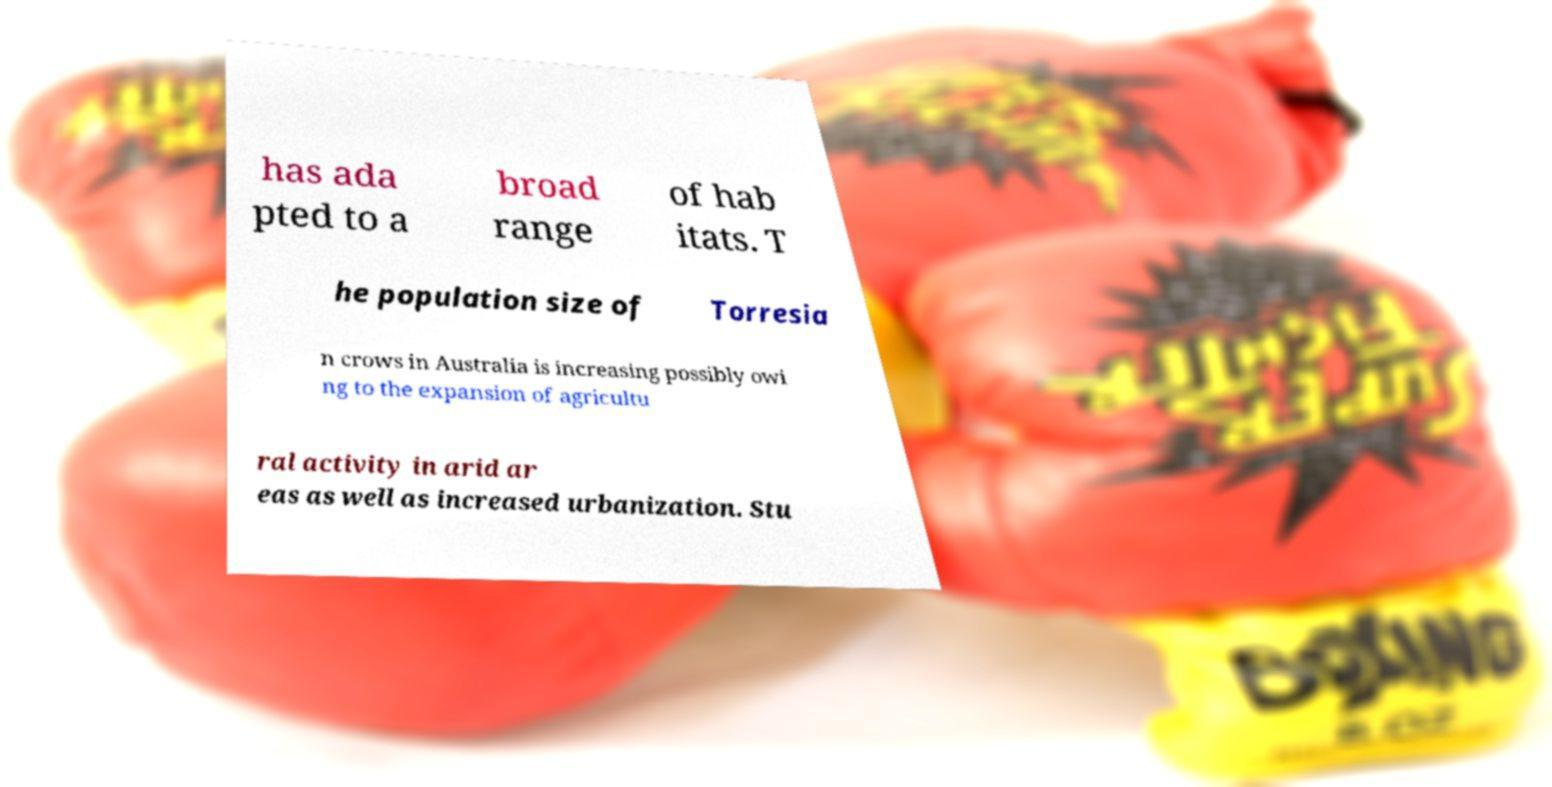There's text embedded in this image that I need extracted. Can you transcribe it verbatim? has ada pted to a broad range of hab itats. T he population size of Torresia n crows in Australia is increasing possibly owi ng to the expansion of agricultu ral activity in arid ar eas as well as increased urbanization. Stu 